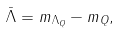<formula> <loc_0><loc_0><loc_500><loc_500>\bar { \Lambda } = m _ { \Lambda _ { Q } } - m _ { Q } ,</formula> 